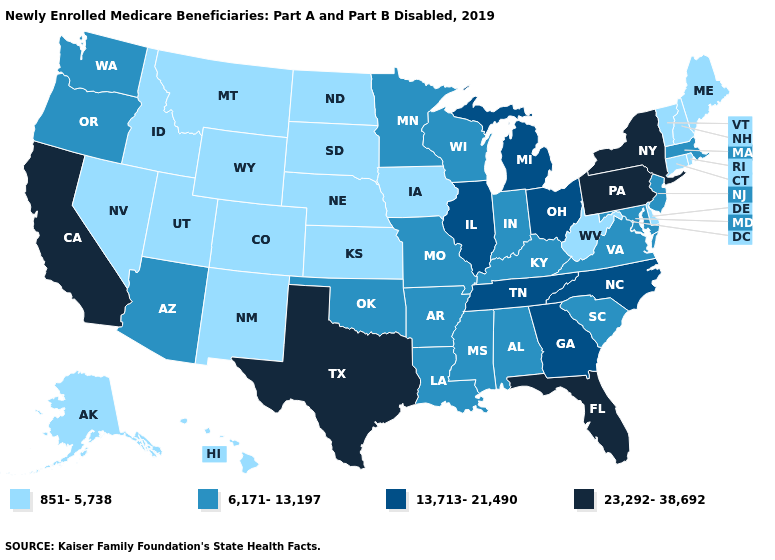Which states hav the highest value in the Northeast?
Quick response, please. New York, Pennsylvania. Which states have the highest value in the USA?
Keep it brief. California, Florida, New York, Pennsylvania, Texas. Which states hav the highest value in the South?
Write a very short answer. Florida, Texas. What is the lowest value in the USA?
Give a very brief answer. 851-5,738. What is the value of Tennessee?
Write a very short answer. 13,713-21,490. Name the states that have a value in the range 851-5,738?
Keep it brief. Alaska, Colorado, Connecticut, Delaware, Hawaii, Idaho, Iowa, Kansas, Maine, Montana, Nebraska, Nevada, New Hampshire, New Mexico, North Dakota, Rhode Island, South Dakota, Utah, Vermont, West Virginia, Wyoming. Name the states that have a value in the range 6,171-13,197?
Write a very short answer. Alabama, Arizona, Arkansas, Indiana, Kentucky, Louisiana, Maryland, Massachusetts, Minnesota, Mississippi, Missouri, New Jersey, Oklahoma, Oregon, South Carolina, Virginia, Washington, Wisconsin. What is the value of Tennessee?
Write a very short answer. 13,713-21,490. Does the first symbol in the legend represent the smallest category?
Give a very brief answer. Yes. Does Pennsylvania have the same value as Oregon?
Concise answer only. No. Name the states that have a value in the range 6,171-13,197?
Write a very short answer. Alabama, Arizona, Arkansas, Indiana, Kentucky, Louisiana, Maryland, Massachusetts, Minnesota, Mississippi, Missouri, New Jersey, Oklahoma, Oregon, South Carolina, Virginia, Washington, Wisconsin. How many symbols are there in the legend?
Be succinct. 4. Does Kansas have a higher value than Wisconsin?
Short answer required. No. Which states have the lowest value in the West?
Concise answer only. Alaska, Colorado, Hawaii, Idaho, Montana, Nevada, New Mexico, Utah, Wyoming. Name the states that have a value in the range 851-5,738?
Answer briefly. Alaska, Colorado, Connecticut, Delaware, Hawaii, Idaho, Iowa, Kansas, Maine, Montana, Nebraska, Nevada, New Hampshire, New Mexico, North Dakota, Rhode Island, South Dakota, Utah, Vermont, West Virginia, Wyoming. 